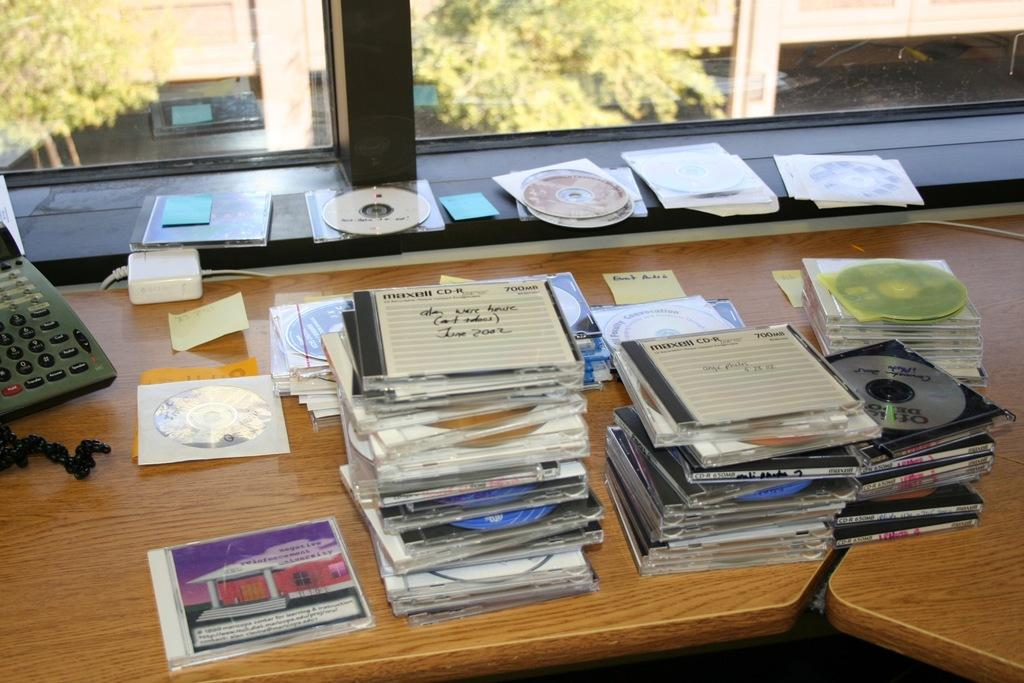What objects are on the table in the image? There are many CDs and a telephone on the table in the image. What can be seen through the glass window in the image? There is a view of buildings and trees from the glass window in the image. What type of ball is being used to play with the arm in the image? There is no ball or arm present in the image. 